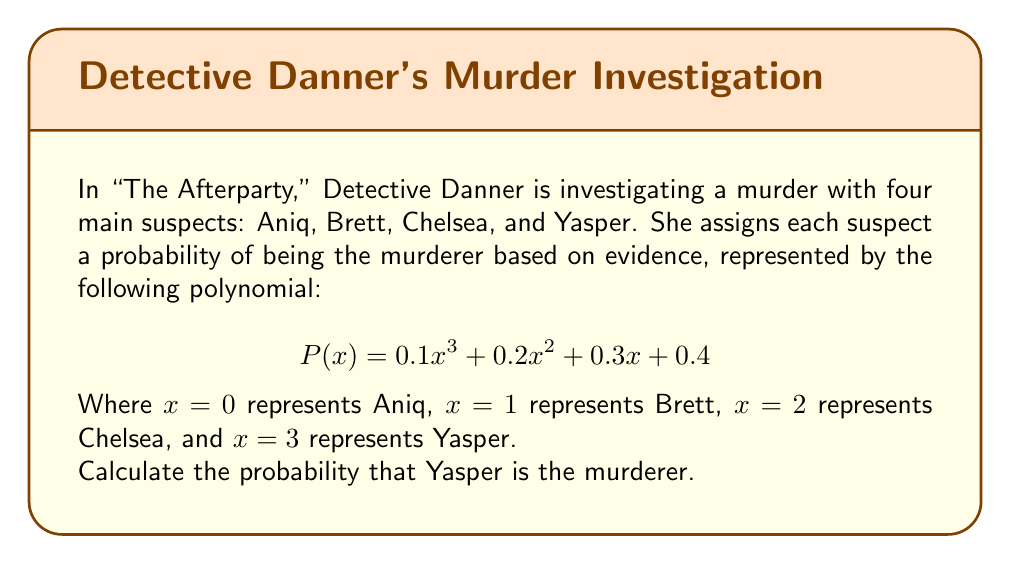Teach me how to tackle this problem. To solve this problem, we need to evaluate the polynomial $P(x)$ at $x = 3$, since Yasper is represented by $x = 3$. Let's break this down step by step:

1) We start with the polynomial:
   $$P(x) = 0.1x^3 + 0.2x^2 + 0.3x + 0.4$$

2) We need to substitute $x = 3$ into this polynomial:
   $$P(3) = 0.1(3^3) + 0.2(3^2) + 0.3(3) + 0.4$$

3) Let's evaluate each term:
   - $0.1(3^3) = 0.1 \cdot 27 = 2.7$
   - $0.2(3^2) = 0.2 \cdot 9 = 1.8$
   - $0.3(3) = 0.9$
   - $0.4$ remains as is

4) Now we can add these terms:
   $$P(3) = 2.7 + 1.8 + 0.9 + 0.4 = 5.8$$

Therefore, the probability that Yasper is the murderer is 5.8 or 580%.

However, probabilities cannot exceed 100% or 1. This result indicates that the polynomial doesn't represent a valid probability distribution. In a real investigation, Detective Danner would need to normalize these values to ensure they sum to 1 across all suspects.
Answer: $5.8$ or $580\%$ (noting that this exceeds 100% and thus isn't a valid probability in practice) 